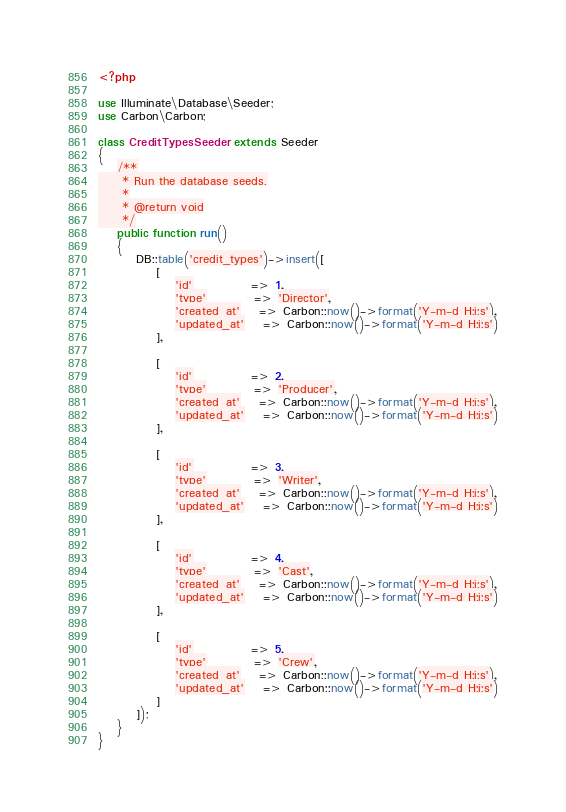Convert code to text. <code><loc_0><loc_0><loc_500><loc_500><_PHP_><?php

use Illuminate\Database\Seeder;
use Carbon\Carbon;

class CreditTypesSeeder extends Seeder
{
    /**
     * Run the database seeds.
     *
     * @return void
     */
    public function run()
    {
        DB::table('credit_types')->insert([
            [
                'id'            => 1,
                'type'          => 'Director',
                'created_at'    => Carbon::now()->format('Y-m-d H:i:s'),
                'updated_at'    => Carbon::now()->format('Y-m-d H:i:s')
            ],

            [
                'id'            => 2,
                'type'          => 'Producer',
                'created_at'    => Carbon::now()->format('Y-m-d H:i:s'),
                'updated_at'    => Carbon::now()->format('Y-m-d H:i:s')
            ],

            [
                'id'            => 3,
                'type'          => 'Writer',
                'created_at'    => Carbon::now()->format('Y-m-d H:i:s'),
                'updated_at'    => Carbon::now()->format('Y-m-d H:i:s')
            ],

            [
                'id'            => 4,
                'type'          => 'Cast',
                'created_at'    => Carbon::now()->format('Y-m-d H:i:s'),
                'updated_at'    => Carbon::now()->format('Y-m-d H:i:s')
            ],

            [
                'id'            => 5,
                'type'          => 'Crew',
                'created_at'    => Carbon::now()->format('Y-m-d H:i:s'),
                'updated_at'    => Carbon::now()->format('Y-m-d H:i:s')
            ]
        ]);
    }
}
</code> 